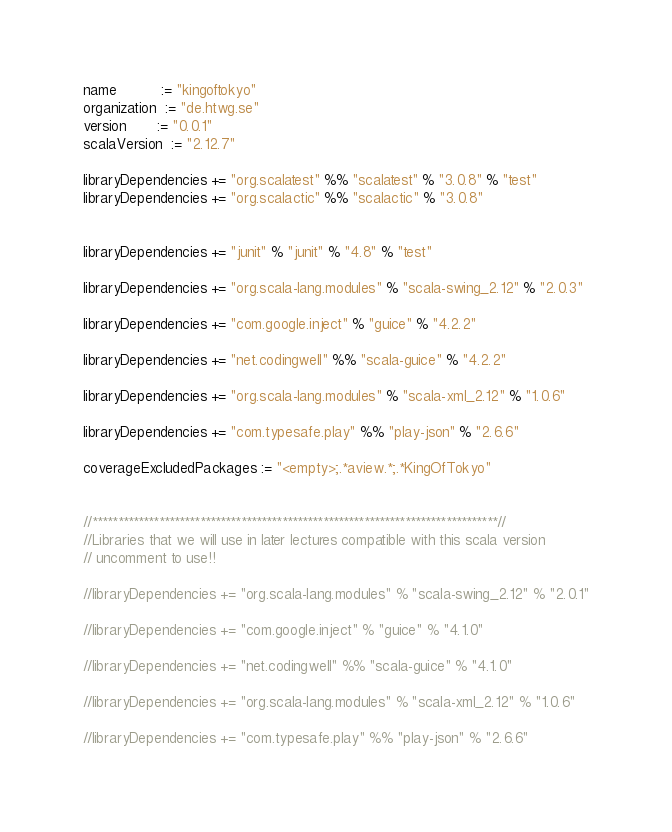<code> <loc_0><loc_0><loc_500><loc_500><_Scala_>
name          := "kingoftokyo"
organization  := "de.htwg.se"
version       := "0.0.1"
scalaVersion  := "2.12.7"

libraryDependencies += "org.scalatest" %% "scalatest" % "3.0.8" % "test"
libraryDependencies += "org.scalactic" %% "scalactic" % "3.0.8"


libraryDependencies += "junit" % "junit" % "4.8" % "test"

libraryDependencies += "org.scala-lang.modules" % "scala-swing_2.12" % "2.0.3"

libraryDependencies += "com.google.inject" % "guice" % "4.2.2"

libraryDependencies += "net.codingwell" %% "scala-guice" % "4.2.2"

libraryDependencies += "org.scala-lang.modules" % "scala-xml_2.12" % "1.0.6"

libraryDependencies += "com.typesafe.play" %% "play-json" % "2.6.6"

coverageExcludedPackages := "<empty>;.*aview.*;.*KingOfTokyo"


//*******************************************************************************//
//Libraries that we will use in later lectures compatible with this scala version
// uncomment to use!!

//libraryDependencies += "org.scala-lang.modules" % "scala-swing_2.12" % "2.0.1"

//libraryDependencies += "com.google.inject" % "guice" % "4.1.0"

//libraryDependencies += "net.codingwell" %% "scala-guice" % "4.1.0"

//libraryDependencies += "org.scala-lang.modules" % "scala-xml_2.12" % "1.0.6"

//libraryDependencies += "com.typesafe.play" %% "play-json" % "2.6.6"
</code> 